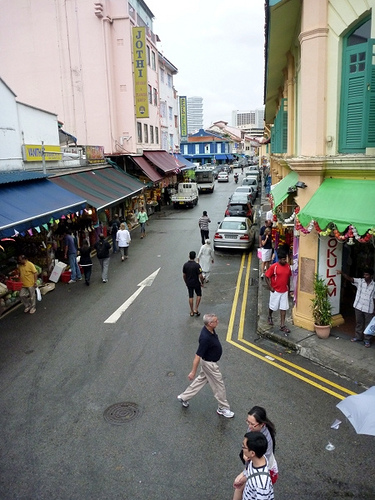<image>
Is there a man in front of the woman? No. The man is not in front of the woman. The spatial positioning shows a different relationship between these objects. Where is the awning in relation to the man? Is it above the man? Yes. The awning is positioned above the man in the vertical space, higher up in the scene. 